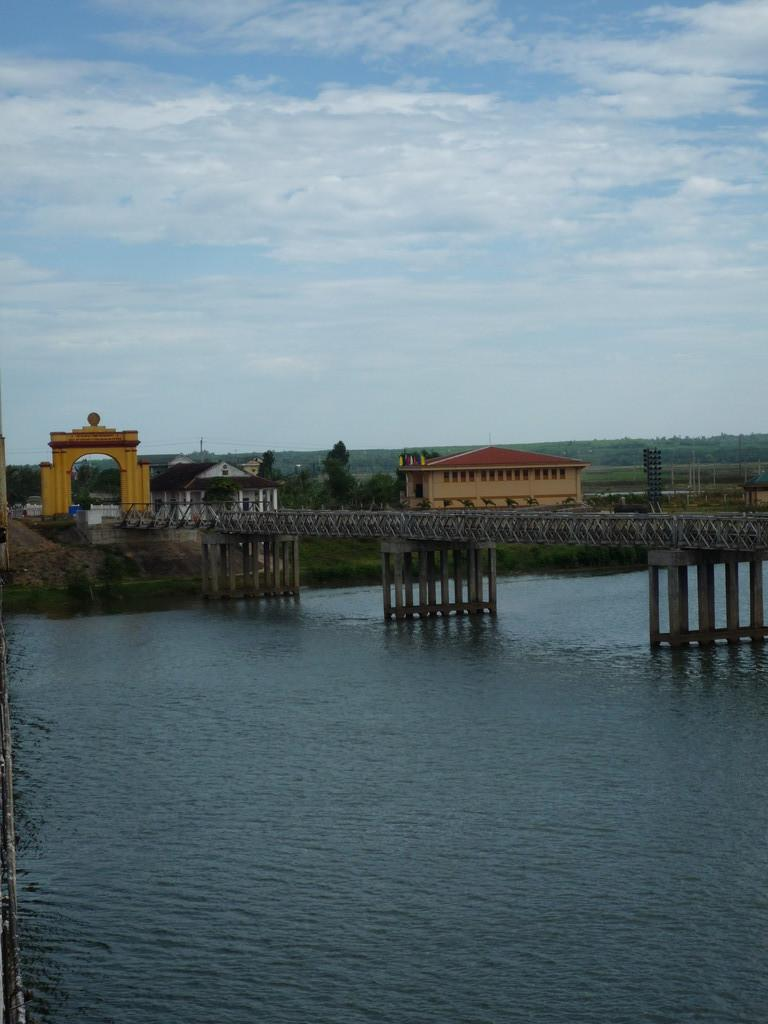What structure can be seen in the image? There is a bridge in the image. What is located behind the bridge? There is a house with a red-colored rooftop behind the bridge. What is beside the house? There is a tree beside the house. What can be seen below the bridge? Water is visible below the bridge. What is visible at the top of the image? The sky is visible at the top of the image. What type of plant does your dad have in his memory garden? There is no mention of a plant, dad, or memory garden in the image. 